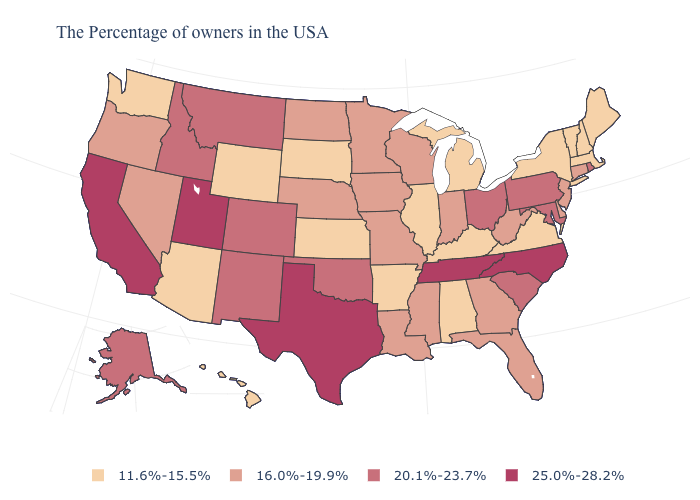What is the value of South Dakota?
Short answer required. 11.6%-15.5%. What is the highest value in the USA?
Concise answer only. 25.0%-28.2%. What is the value of North Dakota?
Answer briefly. 16.0%-19.9%. What is the value of Georgia?
Concise answer only. 16.0%-19.9%. What is the highest value in the USA?
Write a very short answer. 25.0%-28.2%. Does Vermont have the lowest value in the Northeast?
Write a very short answer. Yes. Does the map have missing data?
Keep it brief. No. Among the states that border Maryland , which have the lowest value?
Answer briefly. Virginia. Does Nevada have a lower value than Oregon?
Be succinct. No. Does Vermont have the same value as Kentucky?
Quick response, please. Yes. What is the value of Connecticut?
Quick response, please. 16.0%-19.9%. Name the states that have a value in the range 16.0%-19.9%?
Short answer required. Connecticut, New Jersey, Delaware, West Virginia, Florida, Georgia, Indiana, Wisconsin, Mississippi, Louisiana, Missouri, Minnesota, Iowa, Nebraska, North Dakota, Nevada, Oregon. What is the value of Pennsylvania?
Be succinct. 20.1%-23.7%. What is the lowest value in the MidWest?
Quick response, please. 11.6%-15.5%. Does North Carolina have the highest value in the USA?
Answer briefly. Yes. 